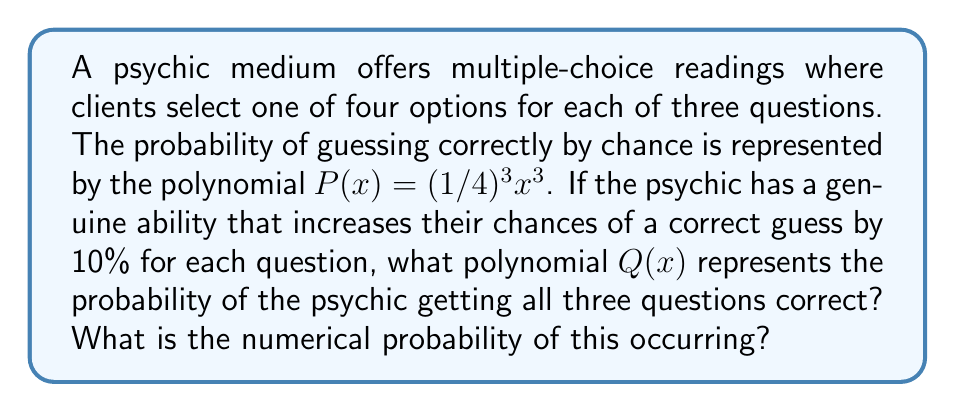Could you help me with this problem? Let's approach this step-by-step:

1) The base probability of guessing correctly for each question is 1/4 or 0.25.

2) The psychic's ability increases this probability by 10% (0.1) for each question.

3) So, the probability of the psychic getting each question correct is:
   $0.25 + 0.1 = 0.35$ or $35\%$

4) For all three questions to be correct, we need to multiply these probabilities:
   $(0.35)^3$

5) To represent this as a polynomial $Q(x)$, we use:
   $Q(x) = (0.35)^3x^3$

6) To calculate the numerical probability:
   $Q(1) = (0.35)^3 = 0.042875$

7) We can verify that this is indeed a higher probability than random guessing:
   $P(1) = (1/4)^3 = 0.015625$

   $0.042875 > 0.015625$

Therefore, the polynomial representing the psychic's improved probability is $Q(x) = 0.042875x^3$, and the numerical probability is approximately 0.042875 or 4.2875%.
Answer: $Q(x) = 0.042875x^3$; Probability $\approx 0.042875$ or $4.2875\%$ 